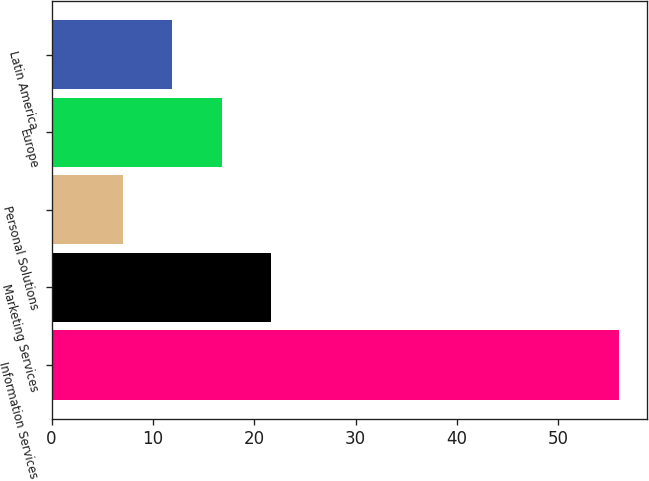<chart> <loc_0><loc_0><loc_500><loc_500><bar_chart><fcel>Information Services<fcel>Marketing Services<fcel>Personal Solutions<fcel>Europe<fcel>Latin America<nl><fcel>56<fcel>21.7<fcel>7<fcel>16.8<fcel>11.9<nl></chart> 